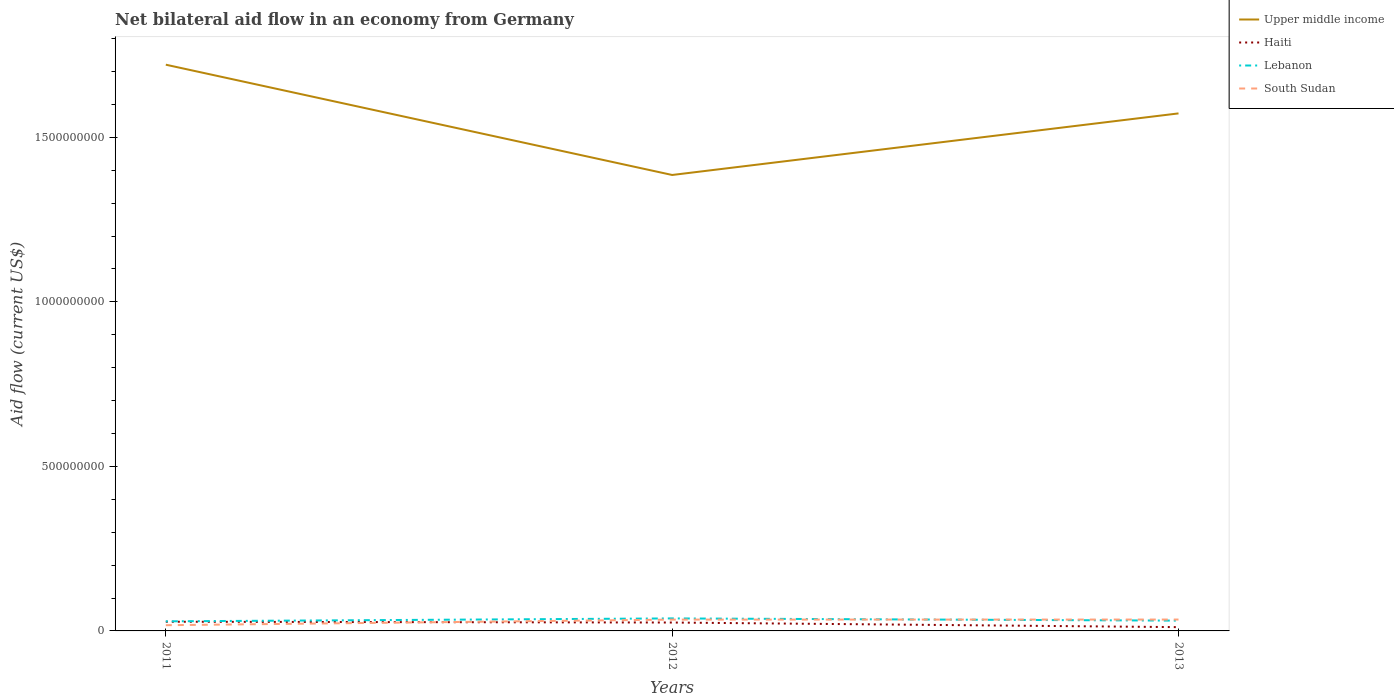How many different coloured lines are there?
Ensure brevity in your answer.  4. Is the number of lines equal to the number of legend labels?
Provide a short and direct response. Yes. Across all years, what is the maximum net bilateral aid flow in Upper middle income?
Provide a short and direct response. 1.39e+09. What is the total net bilateral aid flow in Upper middle income in the graph?
Offer a terse response. 3.35e+08. What is the difference between the highest and the second highest net bilateral aid flow in South Sudan?
Ensure brevity in your answer.  1.72e+07. How many lines are there?
Ensure brevity in your answer.  4. How many years are there in the graph?
Your response must be concise. 3. What is the difference between two consecutive major ticks on the Y-axis?
Your answer should be compact. 5.00e+08. Are the values on the major ticks of Y-axis written in scientific E-notation?
Provide a short and direct response. No. Does the graph contain grids?
Provide a short and direct response. No. How are the legend labels stacked?
Your response must be concise. Vertical. What is the title of the graph?
Provide a succinct answer. Net bilateral aid flow in an economy from Germany. What is the label or title of the Y-axis?
Keep it short and to the point. Aid flow (current US$). What is the Aid flow (current US$) in Upper middle income in 2011?
Make the answer very short. 1.72e+09. What is the Aid flow (current US$) of Haiti in 2011?
Your answer should be very brief. 2.79e+07. What is the Aid flow (current US$) of Lebanon in 2011?
Make the answer very short. 2.92e+07. What is the Aid flow (current US$) in South Sudan in 2011?
Provide a short and direct response. 1.74e+07. What is the Aid flow (current US$) of Upper middle income in 2012?
Your answer should be very brief. 1.39e+09. What is the Aid flow (current US$) of Haiti in 2012?
Keep it short and to the point. 2.55e+07. What is the Aid flow (current US$) of Lebanon in 2012?
Your answer should be compact. 3.80e+07. What is the Aid flow (current US$) of South Sudan in 2012?
Offer a very short reply. 3.44e+07. What is the Aid flow (current US$) in Upper middle income in 2013?
Ensure brevity in your answer.  1.57e+09. What is the Aid flow (current US$) of Haiti in 2013?
Provide a short and direct response. 1.15e+07. What is the Aid flow (current US$) in Lebanon in 2013?
Your response must be concise. 3.13e+07. What is the Aid flow (current US$) in South Sudan in 2013?
Your response must be concise. 3.46e+07. Across all years, what is the maximum Aid flow (current US$) in Upper middle income?
Keep it short and to the point. 1.72e+09. Across all years, what is the maximum Aid flow (current US$) of Haiti?
Make the answer very short. 2.79e+07. Across all years, what is the maximum Aid flow (current US$) of Lebanon?
Make the answer very short. 3.80e+07. Across all years, what is the maximum Aid flow (current US$) in South Sudan?
Your answer should be very brief. 3.46e+07. Across all years, what is the minimum Aid flow (current US$) in Upper middle income?
Offer a terse response. 1.39e+09. Across all years, what is the minimum Aid flow (current US$) in Haiti?
Provide a short and direct response. 1.15e+07. Across all years, what is the minimum Aid flow (current US$) of Lebanon?
Give a very brief answer. 2.92e+07. Across all years, what is the minimum Aid flow (current US$) in South Sudan?
Give a very brief answer. 1.74e+07. What is the total Aid flow (current US$) in Upper middle income in the graph?
Your answer should be very brief. 4.68e+09. What is the total Aid flow (current US$) in Haiti in the graph?
Offer a terse response. 6.49e+07. What is the total Aid flow (current US$) of Lebanon in the graph?
Provide a short and direct response. 9.84e+07. What is the total Aid flow (current US$) in South Sudan in the graph?
Provide a short and direct response. 8.63e+07. What is the difference between the Aid flow (current US$) in Upper middle income in 2011 and that in 2012?
Your answer should be very brief. 3.35e+08. What is the difference between the Aid flow (current US$) in Haiti in 2011 and that in 2012?
Provide a succinct answer. 2.42e+06. What is the difference between the Aid flow (current US$) in Lebanon in 2011 and that in 2012?
Your response must be concise. -8.86e+06. What is the difference between the Aid flow (current US$) in South Sudan in 2011 and that in 2012?
Your response must be concise. -1.70e+07. What is the difference between the Aid flow (current US$) of Upper middle income in 2011 and that in 2013?
Your response must be concise. 1.48e+08. What is the difference between the Aid flow (current US$) of Haiti in 2011 and that in 2013?
Your answer should be compact. 1.64e+07. What is the difference between the Aid flow (current US$) in Lebanon in 2011 and that in 2013?
Offer a very short reply. -2.11e+06. What is the difference between the Aid flow (current US$) in South Sudan in 2011 and that in 2013?
Your response must be concise. -1.72e+07. What is the difference between the Aid flow (current US$) of Upper middle income in 2012 and that in 2013?
Your response must be concise. -1.87e+08. What is the difference between the Aid flow (current US$) in Haiti in 2012 and that in 2013?
Provide a short and direct response. 1.40e+07. What is the difference between the Aid flow (current US$) of Lebanon in 2012 and that in 2013?
Make the answer very short. 6.75e+06. What is the difference between the Aid flow (current US$) in South Sudan in 2012 and that in 2013?
Your response must be concise. -1.80e+05. What is the difference between the Aid flow (current US$) of Upper middle income in 2011 and the Aid flow (current US$) of Haiti in 2012?
Your response must be concise. 1.70e+09. What is the difference between the Aid flow (current US$) of Upper middle income in 2011 and the Aid flow (current US$) of Lebanon in 2012?
Your answer should be very brief. 1.68e+09. What is the difference between the Aid flow (current US$) of Upper middle income in 2011 and the Aid flow (current US$) of South Sudan in 2012?
Your response must be concise. 1.69e+09. What is the difference between the Aid flow (current US$) in Haiti in 2011 and the Aid flow (current US$) in Lebanon in 2012?
Your answer should be compact. -1.01e+07. What is the difference between the Aid flow (current US$) of Haiti in 2011 and the Aid flow (current US$) of South Sudan in 2012?
Ensure brevity in your answer.  -6.48e+06. What is the difference between the Aid flow (current US$) in Lebanon in 2011 and the Aid flow (current US$) in South Sudan in 2012?
Keep it short and to the point. -5.23e+06. What is the difference between the Aid flow (current US$) of Upper middle income in 2011 and the Aid flow (current US$) of Haiti in 2013?
Your response must be concise. 1.71e+09. What is the difference between the Aid flow (current US$) of Upper middle income in 2011 and the Aid flow (current US$) of Lebanon in 2013?
Provide a short and direct response. 1.69e+09. What is the difference between the Aid flow (current US$) in Upper middle income in 2011 and the Aid flow (current US$) in South Sudan in 2013?
Your response must be concise. 1.69e+09. What is the difference between the Aid flow (current US$) in Haiti in 2011 and the Aid flow (current US$) in Lebanon in 2013?
Give a very brief answer. -3.36e+06. What is the difference between the Aid flow (current US$) of Haiti in 2011 and the Aid flow (current US$) of South Sudan in 2013?
Keep it short and to the point. -6.66e+06. What is the difference between the Aid flow (current US$) of Lebanon in 2011 and the Aid flow (current US$) of South Sudan in 2013?
Your response must be concise. -5.41e+06. What is the difference between the Aid flow (current US$) of Upper middle income in 2012 and the Aid flow (current US$) of Haiti in 2013?
Offer a terse response. 1.37e+09. What is the difference between the Aid flow (current US$) of Upper middle income in 2012 and the Aid flow (current US$) of Lebanon in 2013?
Your answer should be very brief. 1.35e+09. What is the difference between the Aid flow (current US$) in Upper middle income in 2012 and the Aid flow (current US$) in South Sudan in 2013?
Offer a very short reply. 1.35e+09. What is the difference between the Aid flow (current US$) of Haiti in 2012 and the Aid flow (current US$) of Lebanon in 2013?
Make the answer very short. -5.78e+06. What is the difference between the Aid flow (current US$) of Haiti in 2012 and the Aid flow (current US$) of South Sudan in 2013?
Make the answer very short. -9.08e+06. What is the difference between the Aid flow (current US$) in Lebanon in 2012 and the Aid flow (current US$) in South Sudan in 2013?
Your answer should be compact. 3.45e+06. What is the average Aid flow (current US$) of Upper middle income per year?
Offer a very short reply. 1.56e+09. What is the average Aid flow (current US$) of Haiti per year?
Give a very brief answer. 2.16e+07. What is the average Aid flow (current US$) in Lebanon per year?
Make the answer very short. 3.28e+07. What is the average Aid flow (current US$) in South Sudan per year?
Your response must be concise. 2.88e+07. In the year 2011, what is the difference between the Aid flow (current US$) of Upper middle income and Aid flow (current US$) of Haiti?
Make the answer very short. 1.69e+09. In the year 2011, what is the difference between the Aid flow (current US$) of Upper middle income and Aid flow (current US$) of Lebanon?
Keep it short and to the point. 1.69e+09. In the year 2011, what is the difference between the Aid flow (current US$) in Upper middle income and Aid flow (current US$) in South Sudan?
Provide a short and direct response. 1.70e+09. In the year 2011, what is the difference between the Aid flow (current US$) in Haiti and Aid flow (current US$) in Lebanon?
Your response must be concise. -1.25e+06. In the year 2011, what is the difference between the Aid flow (current US$) of Haiti and Aid flow (current US$) of South Sudan?
Give a very brief answer. 1.05e+07. In the year 2011, what is the difference between the Aid flow (current US$) in Lebanon and Aid flow (current US$) in South Sudan?
Offer a terse response. 1.18e+07. In the year 2012, what is the difference between the Aid flow (current US$) in Upper middle income and Aid flow (current US$) in Haiti?
Your response must be concise. 1.36e+09. In the year 2012, what is the difference between the Aid flow (current US$) in Upper middle income and Aid flow (current US$) in Lebanon?
Offer a terse response. 1.35e+09. In the year 2012, what is the difference between the Aid flow (current US$) in Upper middle income and Aid flow (current US$) in South Sudan?
Your response must be concise. 1.35e+09. In the year 2012, what is the difference between the Aid flow (current US$) in Haiti and Aid flow (current US$) in Lebanon?
Provide a short and direct response. -1.25e+07. In the year 2012, what is the difference between the Aid flow (current US$) of Haiti and Aid flow (current US$) of South Sudan?
Make the answer very short. -8.90e+06. In the year 2012, what is the difference between the Aid flow (current US$) in Lebanon and Aid flow (current US$) in South Sudan?
Your answer should be very brief. 3.63e+06. In the year 2013, what is the difference between the Aid flow (current US$) in Upper middle income and Aid flow (current US$) in Haiti?
Keep it short and to the point. 1.56e+09. In the year 2013, what is the difference between the Aid flow (current US$) in Upper middle income and Aid flow (current US$) in Lebanon?
Your response must be concise. 1.54e+09. In the year 2013, what is the difference between the Aid flow (current US$) in Upper middle income and Aid flow (current US$) in South Sudan?
Ensure brevity in your answer.  1.54e+09. In the year 2013, what is the difference between the Aid flow (current US$) of Haiti and Aid flow (current US$) of Lebanon?
Ensure brevity in your answer.  -1.98e+07. In the year 2013, what is the difference between the Aid flow (current US$) in Haiti and Aid flow (current US$) in South Sudan?
Ensure brevity in your answer.  -2.31e+07. In the year 2013, what is the difference between the Aid flow (current US$) in Lebanon and Aid flow (current US$) in South Sudan?
Provide a succinct answer. -3.30e+06. What is the ratio of the Aid flow (current US$) in Upper middle income in 2011 to that in 2012?
Make the answer very short. 1.24. What is the ratio of the Aid flow (current US$) in Haiti in 2011 to that in 2012?
Your answer should be compact. 1.09. What is the ratio of the Aid flow (current US$) in Lebanon in 2011 to that in 2012?
Provide a short and direct response. 0.77. What is the ratio of the Aid flow (current US$) of South Sudan in 2011 to that in 2012?
Provide a short and direct response. 0.51. What is the ratio of the Aid flow (current US$) in Upper middle income in 2011 to that in 2013?
Make the answer very short. 1.09. What is the ratio of the Aid flow (current US$) in Haiti in 2011 to that in 2013?
Your response must be concise. 2.43. What is the ratio of the Aid flow (current US$) in Lebanon in 2011 to that in 2013?
Offer a terse response. 0.93. What is the ratio of the Aid flow (current US$) in South Sudan in 2011 to that in 2013?
Keep it short and to the point. 0.5. What is the ratio of the Aid flow (current US$) of Upper middle income in 2012 to that in 2013?
Your answer should be compact. 0.88. What is the ratio of the Aid flow (current US$) in Haiti in 2012 to that in 2013?
Offer a very short reply. 2.22. What is the ratio of the Aid flow (current US$) of Lebanon in 2012 to that in 2013?
Keep it short and to the point. 1.22. What is the ratio of the Aid flow (current US$) in South Sudan in 2012 to that in 2013?
Your answer should be compact. 0.99. What is the difference between the highest and the second highest Aid flow (current US$) of Upper middle income?
Provide a succinct answer. 1.48e+08. What is the difference between the highest and the second highest Aid flow (current US$) of Haiti?
Your answer should be very brief. 2.42e+06. What is the difference between the highest and the second highest Aid flow (current US$) in Lebanon?
Your response must be concise. 6.75e+06. What is the difference between the highest and the lowest Aid flow (current US$) in Upper middle income?
Ensure brevity in your answer.  3.35e+08. What is the difference between the highest and the lowest Aid flow (current US$) of Haiti?
Ensure brevity in your answer.  1.64e+07. What is the difference between the highest and the lowest Aid flow (current US$) of Lebanon?
Ensure brevity in your answer.  8.86e+06. What is the difference between the highest and the lowest Aid flow (current US$) of South Sudan?
Keep it short and to the point. 1.72e+07. 